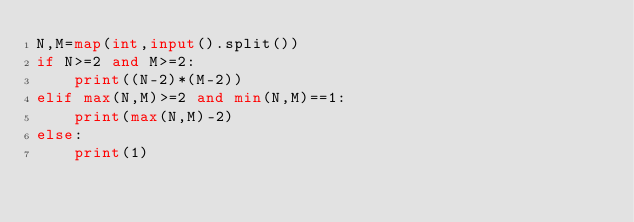<code> <loc_0><loc_0><loc_500><loc_500><_Python_>N,M=map(int,input().split())
if N>=2 and M>=2:
    print((N-2)*(M-2))
elif max(N,M)>=2 and min(N,M)==1:
    print(max(N,M)-2)
else:
    print(1)</code> 